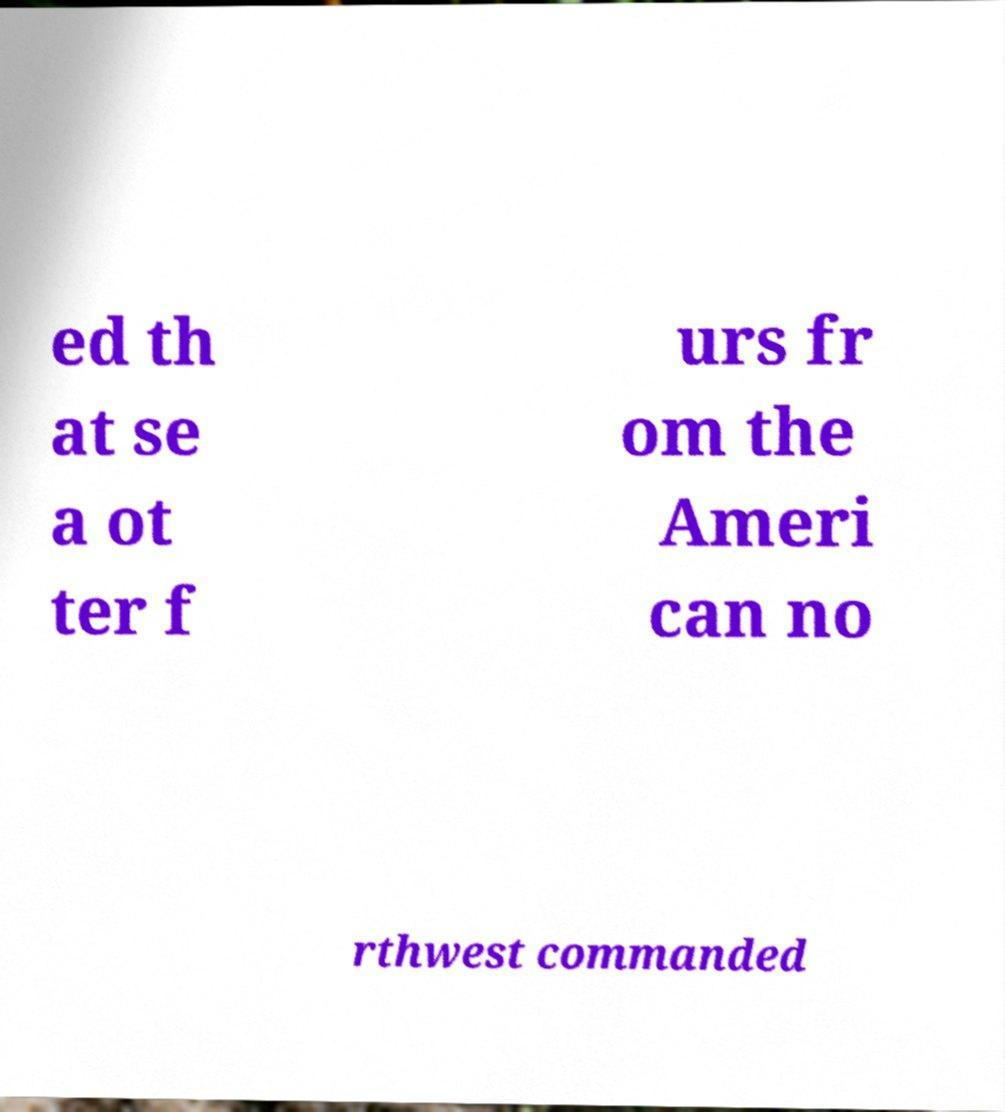Could you assist in decoding the text presented in this image and type it out clearly? ed th at se a ot ter f urs fr om the Ameri can no rthwest commanded 